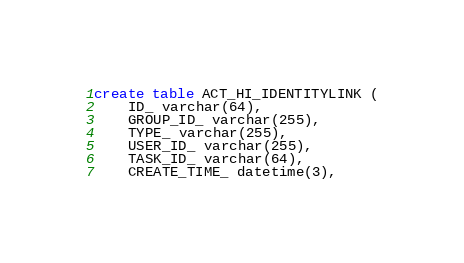<code> <loc_0><loc_0><loc_500><loc_500><_SQL_>create table ACT_HI_IDENTITYLINK (
    ID_ varchar(64),
    GROUP_ID_ varchar(255),
    TYPE_ varchar(255),
    USER_ID_ varchar(255),
    TASK_ID_ varchar(64),
    CREATE_TIME_ datetime(3),</code> 